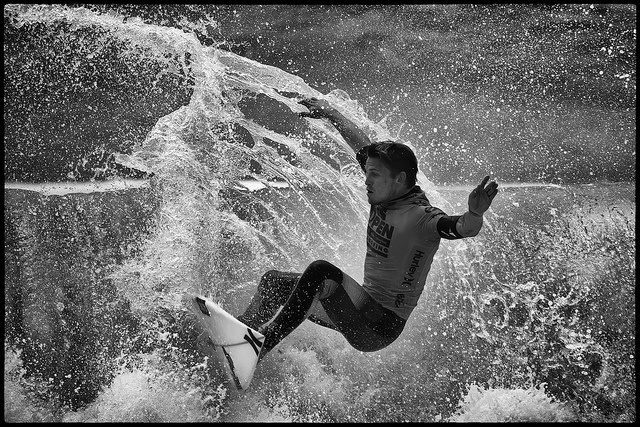Describe the objects in this image and their specific colors. I can see people in black, gray, darkgray, and lightgray tones and surfboard in black, darkgray, gray, and lightgray tones in this image. 